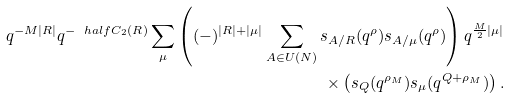<formula> <loc_0><loc_0><loc_500><loc_500>q ^ { - M | R | } q ^ { - \ h a l f C _ { 2 } ( R ) } \sum _ { \mu } \left ( ( - ) ^ { | R | + | \mu | } \sum _ { A \in U ( N ) } s _ { A / R } ( q ^ { \rho } ) s _ { A / \mu } ( q ^ { \rho } ) \right ) q ^ { \frac { M } { 2 } | \mu | } \\ \times \left ( s _ { Q } ( q ^ { \rho _ { M } } ) s _ { \mu } ( q ^ { Q + \rho _ { M } } ) \right ) .</formula> 